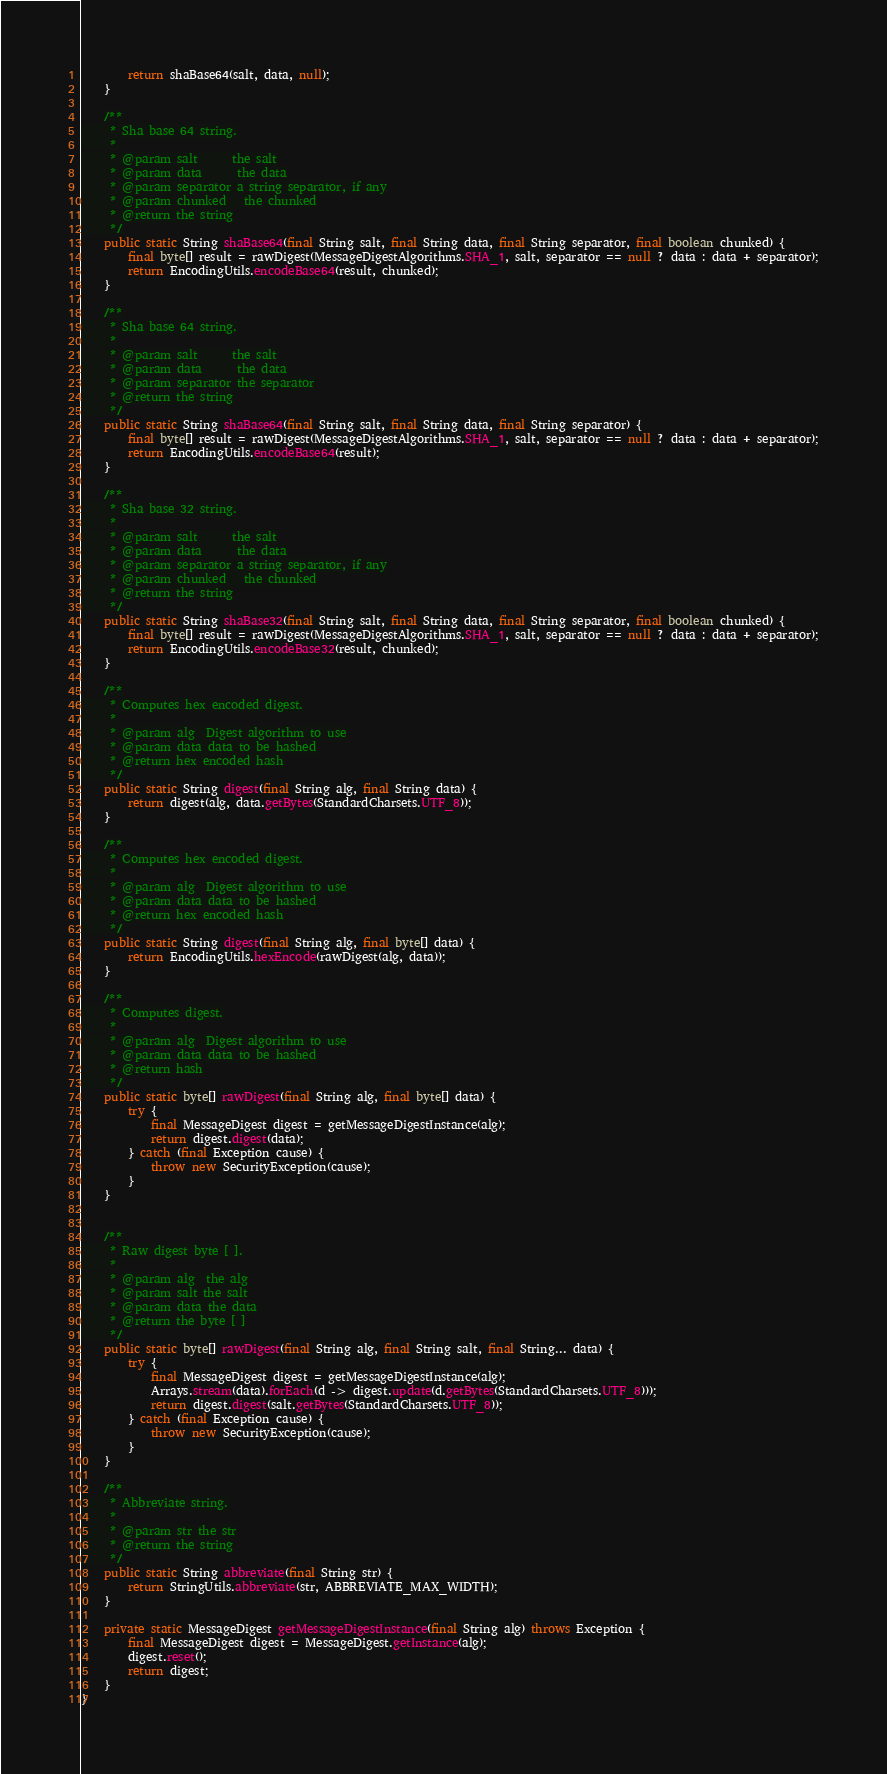<code> <loc_0><loc_0><loc_500><loc_500><_Java_>        return shaBase64(salt, data, null);
    }

    /**
     * Sha base 64 string.
     *
     * @param salt      the salt
     * @param data      the data
     * @param separator a string separator, if any
     * @param chunked   the chunked
     * @return the string
     */
    public static String shaBase64(final String salt, final String data, final String separator, final boolean chunked) {
        final byte[] result = rawDigest(MessageDigestAlgorithms.SHA_1, salt, separator == null ? data : data + separator);
        return EncodingUtils.encodeBase64(result, chunked);
    }

    /**
     * Sha base 64 string.
     *
     * @param salt      the salt
     * @param data      the data
     * @param separator the separator
     * @return the string
     */
    public static String shaBase64(final String salt, final String data, final String separator) {
        final byte[] result = rawDigest(MessageDigestAlgorithms.SHA_1, salt, separator == null ? data : data + separator);
        return EncodingUtils.encodeBase64(result);
    }

    /**
     * Sha base 32 string.
     *
     * @param salt      the salt
     * @param data      the data
     * @param separator a string separator, if any
     * @param chunked   the chunked
     * @return the string
     */
    public static String shaBase32(final String salt, final String data, final String separator, final boolean chunked) {
        final byte[] result = rawDigest(MessageDigestAlgorithms.SHA_1, salt, separator == null ? data : data + separator);
        return EncodingUtils.encodeBase32(result, chunked);
    }

    /**
     * Computes hex encoded digest.
     *
     * @param alg  Digest algorithm to use
     * @param data data to be hashed
     * @return hex encoded hash
     */
    public static String digest(final String alg, final String data) {
        return digest(alg, data.getBytes(StandardCharsets.UTF_8));
    }

    /**
     * Computes hex encoded digest.
     *
     * @param alg  Digest algorithm to use
     * @param data data to be hashed
     * @return hex encoded hash
     */
    public static String digest(final String alg, final byte[] data) {
        return EncodingUtils.hexEncode(rawDigest(alg, data));
    }

    /**
     * Computes digest.
     *
     * @param alg  Digest algorithm to use
     * @param data data to be hashed
     * @return hash
     */
    public static byte[] rawDigest(final String alg, final byte[] data) {
        try {
            final MessageDigest digest = getMessageDigestInstance(alg);
            return digest.digest(data);
        } catch (final Exception cause) {
            throw new SecurityException(cause);
        }
    }


    /**
     * Raw digest byte [ ].
     *
     * @param alg  the alg
     * @param salt the salt
     * @param data the data
     * @return the byte [ ]
     */
    public static byte[] rawDigest(final String alg, final String salt, final String... data) {
        try {
            final MessageDigest digest = getMessageDigestInstance(alg);
            Arrays.stream(data).forEach(d -> digest.update(d.getBytes(StandardCharsets.UTF_8)));
            return digest.digest(salt.getBytes(StandardCharsets.UTF_8));
        } catch (final Exception cause) {
            throw new SecurityException(cause);
        }
    }

    /**
     * Abbreviate string.
     *
     * @param str the str
     * @return the string
     */
    public static String abbreviate(final String str) {
        return StringUtils.abbreviate(str, ABBREVIATE_MAX_WIDTH);
    }

    private static MessageDigest getMessageDigestInstance(final String alg) throws Exception {
        final MessageDigest digest = MessageDigest.getInstance(alg);
        digest.reset();
        return digest;
    }
}
</code> 